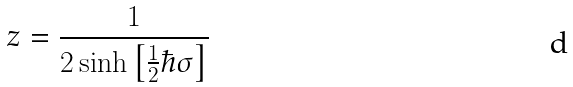Convert formula to latex. <formula><loc_0><loc_0><loc_500><loc_500>z = \frac { 1 } { 2 \sinh \left [ \frac { 1 } { 2 } \hbar { \sigma } \right ] }</formula> 